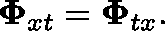Convert formula to latex. <formula><loc_0><loc_0><loc_500><loc_500>\Phi _ { x t } = \Phi _ { t x } .</formula> 